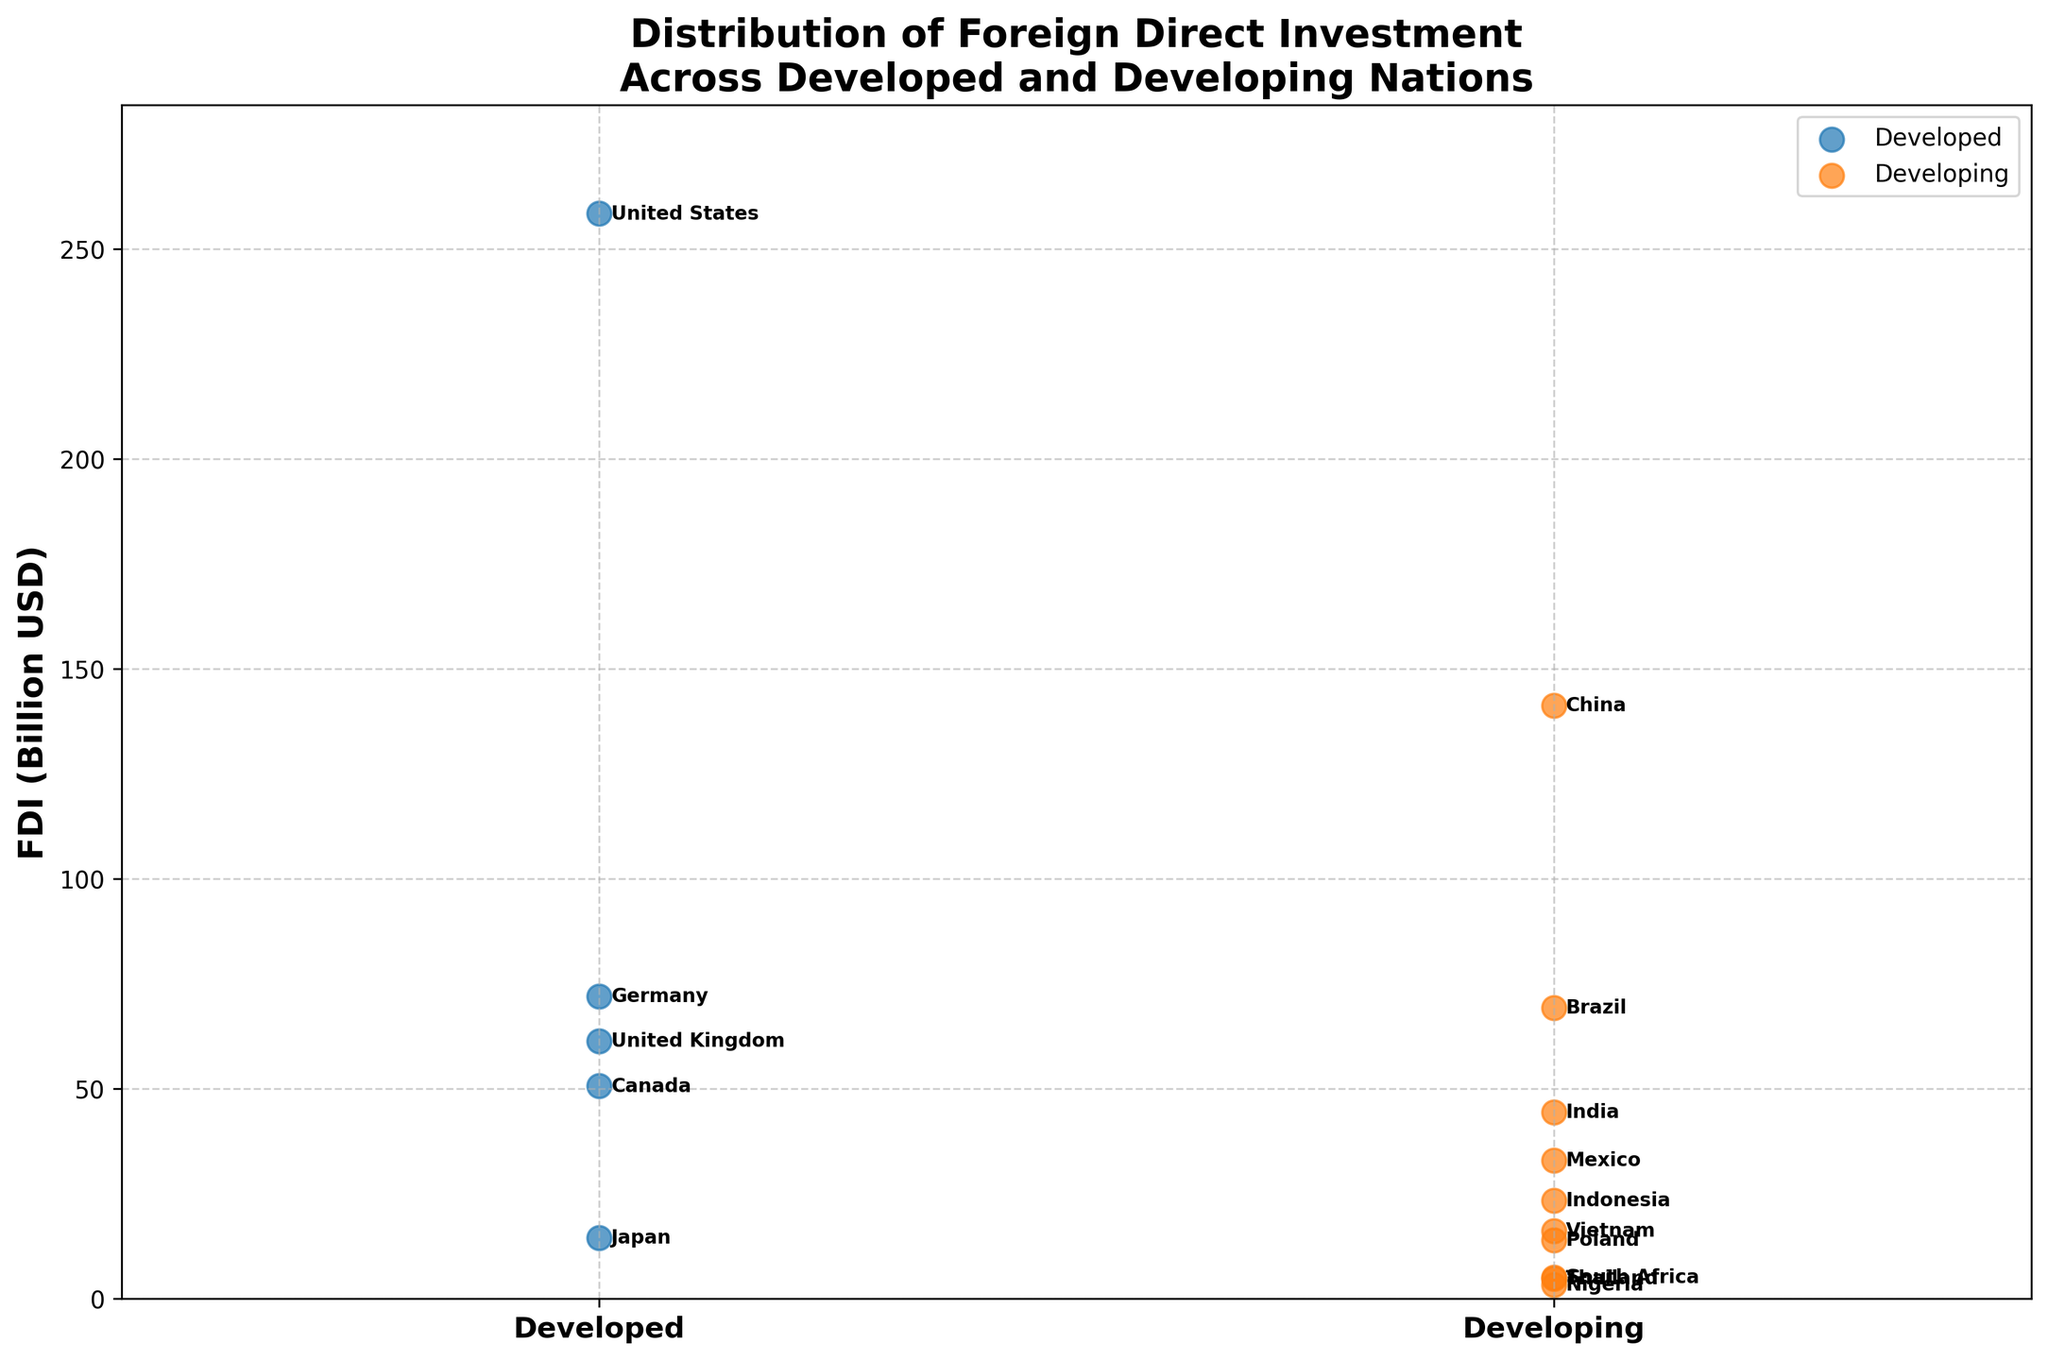What is the title of the figure? The title is mentioned at the top of the figure. It reads "Distribution of Foreign Direct Investment Across Developed and Developing Nations."
Answer: Distribution of Foreign Direct Investment Across Developed and Developing Nations Which nation has the highest FDI among developing countries? The strip plot shows each nation's FDI, and among developing countries, China has the highest FDI. This is indicated by the highest point on the ‘Developing’ side with the label "China."
Answer: China On which side of the plot do developing nations appear? The developing nations are plotted on the right side of the plot, indicated by the label "Developing" on the x-axis.
Answer: Right side How does the FDI of the United States compare to that of China? The United States is a developed nation with an FDI of 258.4 billion USD, and China is a developing nation with an FDI of 141.2 billion USD. By comparing the heights of the points, the United States has a higher FDI than China.
Answer: The United States has higher FDI than China What is the FDI value of the nation labeled "Germany"? "Germany" is labeled under the developed nations category, and its corresponding FDI value is marked at 72.0 billion USD on the y-axis.
Answer: 72.0 billion USD Compare the average FDI of developed and developing nations. Which is higher? To compare the averages, add the FDIs of developed and developing nations and divide by the number of countries in each group. Developed nations' FDI sum: 258.4 + 61.3 + 72.0 + 14.5 + 50.6 = 456.8. Number of developed countries: 5. Average = 456.8 / 5 = 91.36 billion USD. Developing nations' FDI sum: 141.2 + 44.4 + 69.2 + 32.9 + 23.4 + 5.1 + 3.3 + 13.9 + 16.1 + 4.8 = 354.3. Number of developing countries: 10. Average = 354.3 / 10 = 35.43 billion USD. The average FDI is higher for developed nations.
Answer: Developed nations Which developing nation has the lowest FDI, and what is its value? By observing the developing nations, Nigeria has the lowest point, labeled with an FDI value of 3.3 billion USD.
Answer: Nigeria, 3.3 billion USD Is the range of FDIs wider for developed or developing nations? The range is calculated by subtracting the smallest FDI from the largest within each group. Developed nations range: 258.4 - 14.5 = 243.9 billion USD. Developing nations range: 141.2 - 3.3 = 137.9 billion USD. The range is wider for developed nations.
Answer: Developed nations What is the FDI value for India and how does it compare to Mexico's FDI? India's FDI value is labeled at 44.4 billion USD, and Mexico's FDI is labeled at 32.9 billion USD. India has a higher FDI value than Mexico.
Answer: India: 44.4 billion USD; India has higher FDI than Mexico 